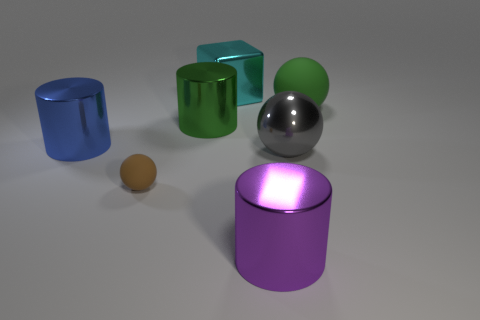Can you describe the texture of the objects in the image? Certainly! The objects in the image exhibit different textures. The cylinders, the sphere, and the cyan cube have smooth, reflective surfaces, suggesting they're quite polished. On the other hand, the two small cubes, one blue and one green, display a texture that's less reflective and looks more matte, giving them a slightly duller appearance. 